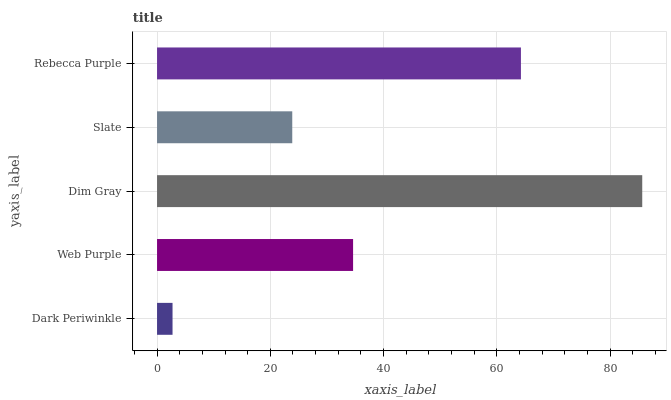Is Dark Periwinkle the minimum?
Answer yes or no. Yes. Is Dim Gray the maximum?
Answer yes or no. Yes. Is Web Purple the minimum?
Answer yes or no. No. Is Web Purple the maximum?
Answer yes or no. No. Is Web Purple greater than Dark Periwinkle?
Answer yes or no. Yes. Is Dark Periwinkle less than Web Purple?
Answer yes or no. Yes. Is Dark Periwinkle greater than Web Purple?
Answer yes or no. No. Is Web Purple less than Dark Periwinkle?
Answer yes or no. No. Is Web Purple the high median?
Answer yes or no. Yes. Is Web Purple the low median?
Answer yes or no. Yes. Is Slate the high median?
Answer yes or no. No. Is Dark Periwinkle the low median?
Answer yes or no. No. 